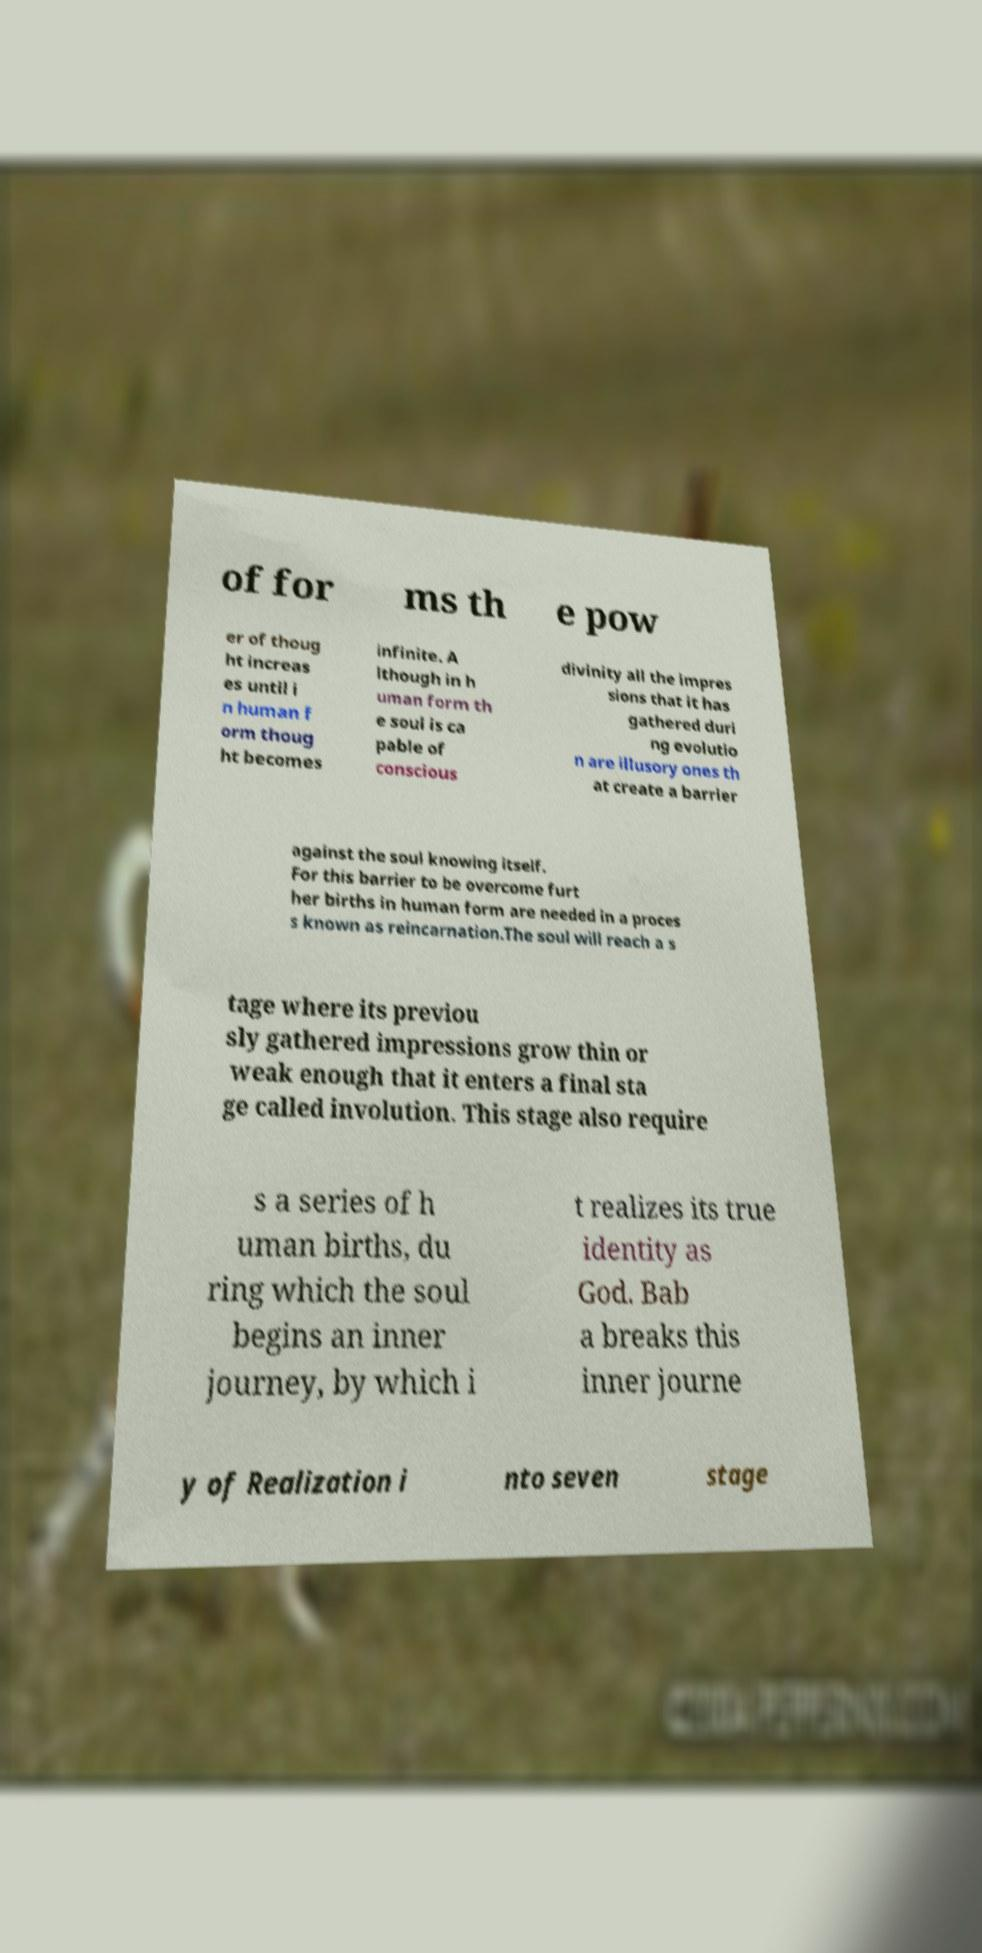For documentation purposes, I need the text within this image transcribed. Could you provide that? of for ms th e pow er of thoug ht increas es until i n human f orm thoug ht becomes infinite. A lthough in h uman form th e soul is ca pable of conscious divinity all the impres sions that it has gathered duri ng evolutio n are illusory ones th at create a barrier against the soul knowing itself. For this barrier to be overcome furt her births in human form are needed in a proces s known as reincarnation.The soul will reach a s tage where its previou sly gathered impressions grow thin or weak enough that it enters a final sta ge called involution. This stage also require s a series of h uman births, du ring which the soul begins an inner journey, by which i t realizes its true identity as God. Bab a breaks this inner journe y of Realization i nto seven stage 